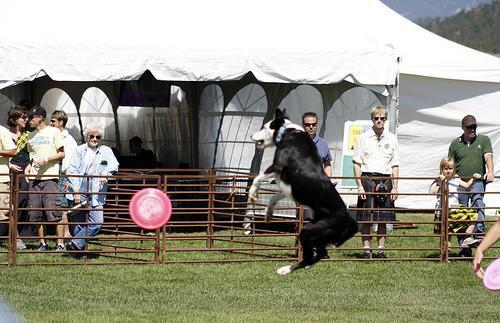How many dogs are in the air?
Give a very brief answer. 1. 